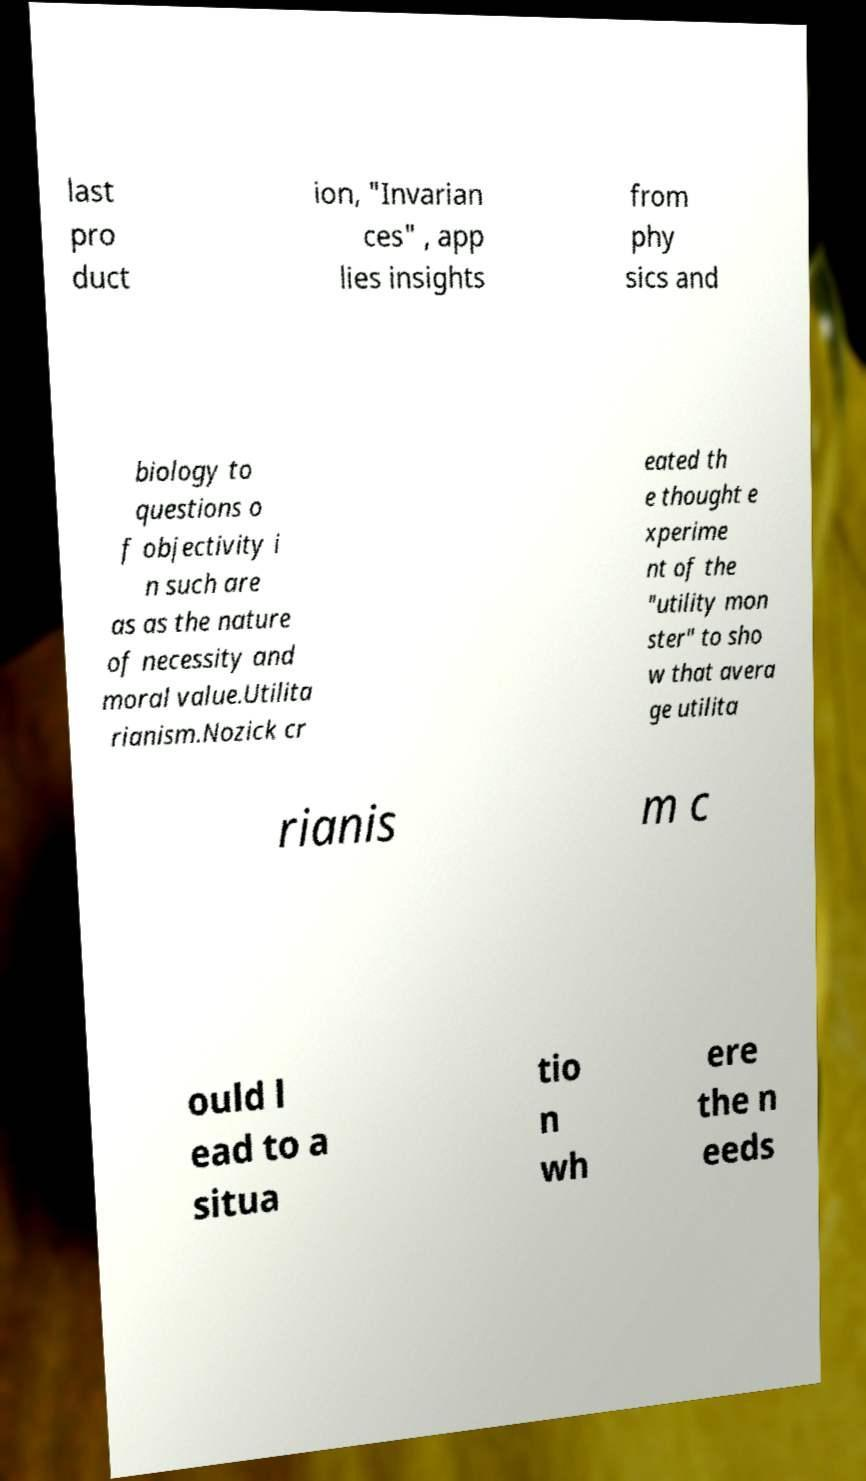Can you read and provide the text displayed in the image?This photo seems to have some interesting text. Can you extract and type it out for me? last pro duct ion, "Invarian ces" , app lies insights from phy sics and biology to questions o f objectivity i n such are as as the nature of necessity and moral value.Utilita rianism.Nozick cr eated th e thought e xperime nt of the "utility mon ster" to sho w that avera ge utilita rianis m c ould l ead to a situa tio n wh ere the n eeds 